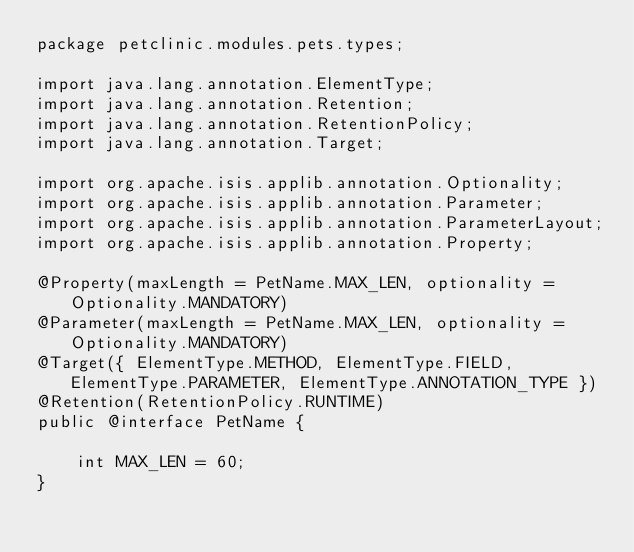<code> <loc_0><loc_0><loc_500><loc_500><_Java_>package petclinic.modules.pets.types;

import java.lang.annotation.ElementType;
import java.lang.annotation.Retention;
import java.lang.annotation.RetentionPolicy;
import java.lang.annotation.Target;

import org.apache.isis.applib.annotation.Optionality;
import org.apache.isis.applib.annotation.Parameter;
import org.apache.isis.applib.annotation.ParameterLayout;
import org.apache.isis.applib.annotation.Property;

@Property(maxLength = PetName.MAX_LEN, optionality = Optionality.MANDATORY)
@Parameter(maxLength = PetName.MAX_LEN, optionality = Optionality.MANDATORY)
@Target({ ElementType.METHOD, ElementType.FIELD, ElementType.PARAMETER, ElementType.ANNOTATION_TYPE })
@Retention(RetentionPolicy.RUNTIME)
public @interface PetName {

    int MAX_LEN = 60;
}
</code> 